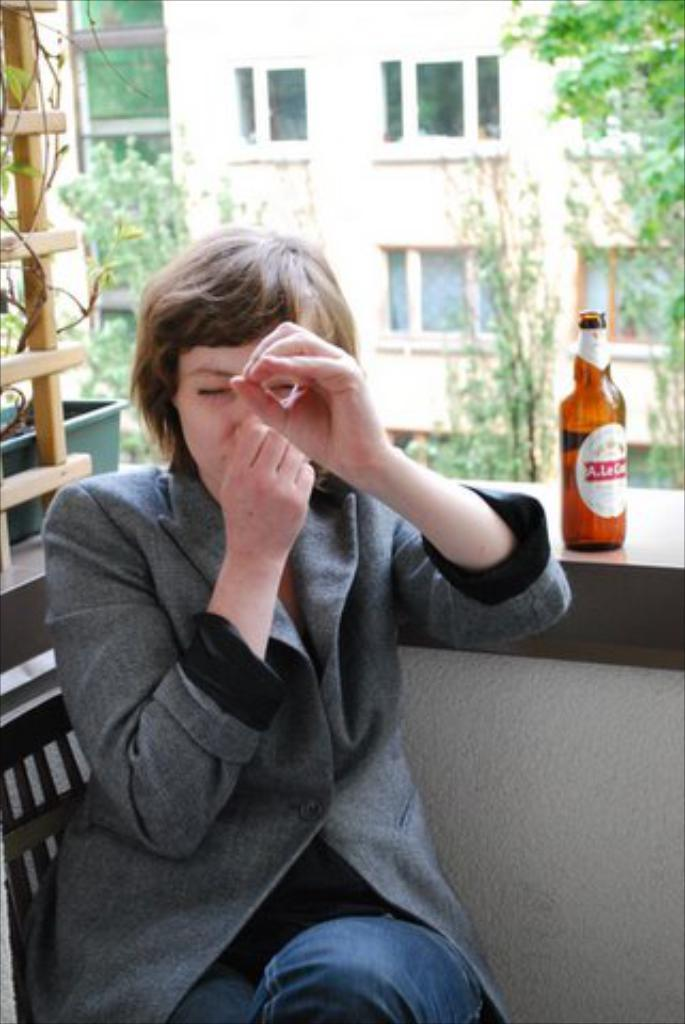Who is present in the image? There is a woman in the image. What is the woman wearing? The woman is wearing a suit. What is the woman doing in the image? The woman is sitting on a chair. What can be seen near the woman? There is a beer bottle in the image, placed on wood. What is visible in the background of the image? There is a building and trees in the background of the image. What type of curtain can be seen hanging from the window in the image? There is no window or curtain present in the image. How many bulbs are visible in the image? There are no bulbs visible in the image. 